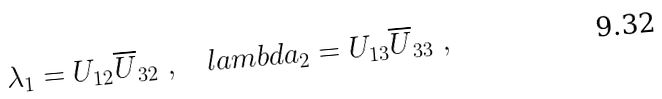Convert formula to latex. <formula><loc_0><loc_0><loc_500><loc_500>\lambda _ { 1 } = U _ { 1 2 } \overline { U } _ { 3 2 } \ , \quad l a m b d a _ { 2 } = U _ { 1 3 } \overline { U } _ { 3 3 } \ ,</formula> 